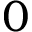<formula> <loc_0><loc_0><loc_500><loc_500>0</formula> 